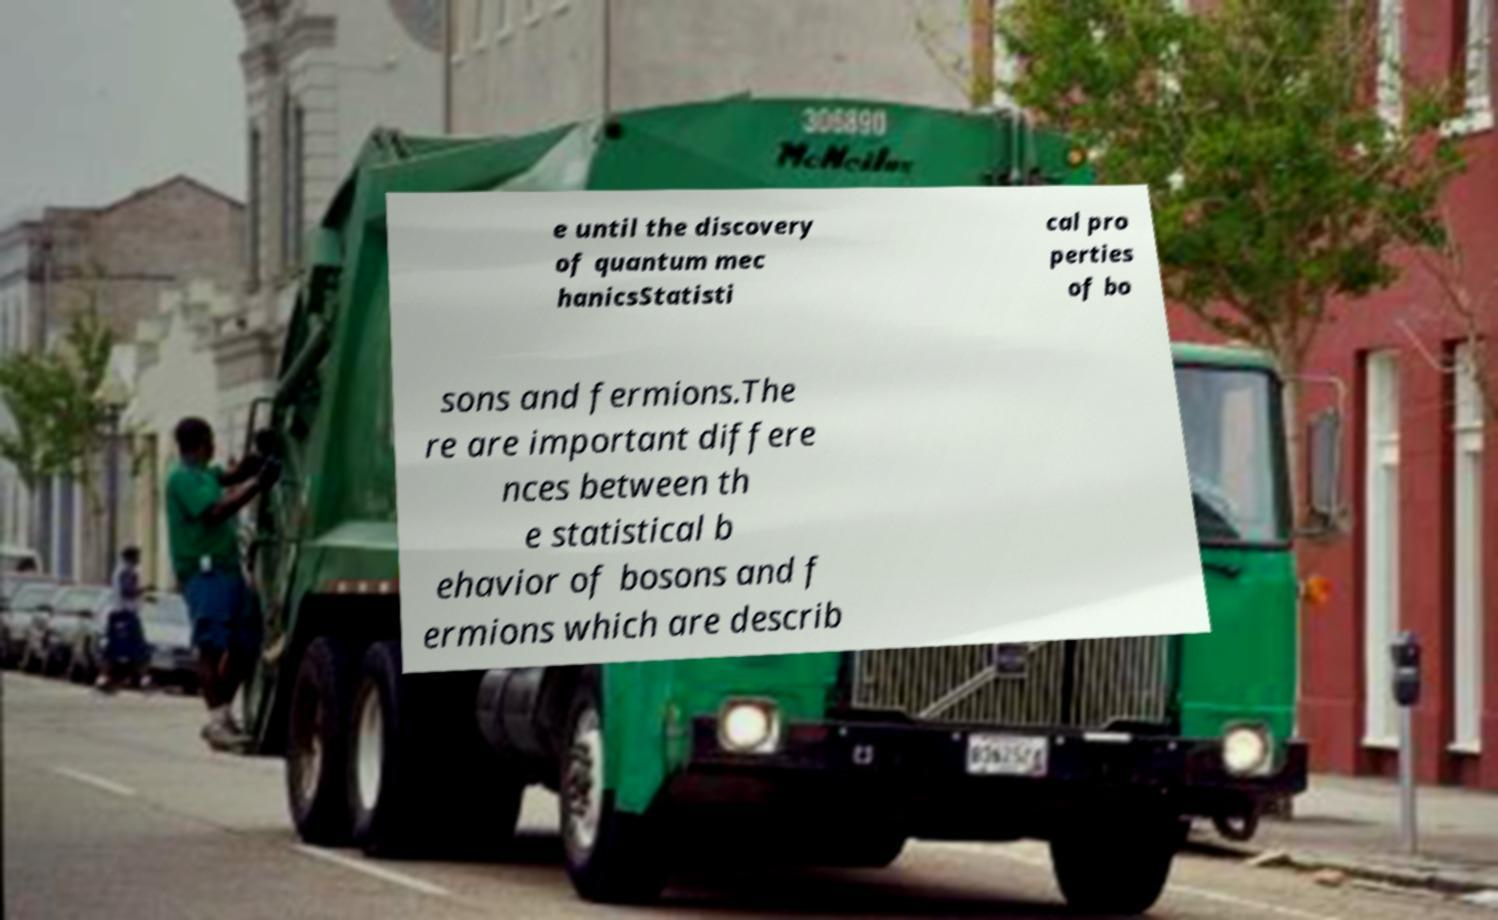Please identify and transcribe the text found in this image. e until the discovery of quantum mec hanicsStatisti cal pro perties of bo sons and fermions.The re are important differe nces between th e statistical b ehavior of bosons and f ermions which are describ 